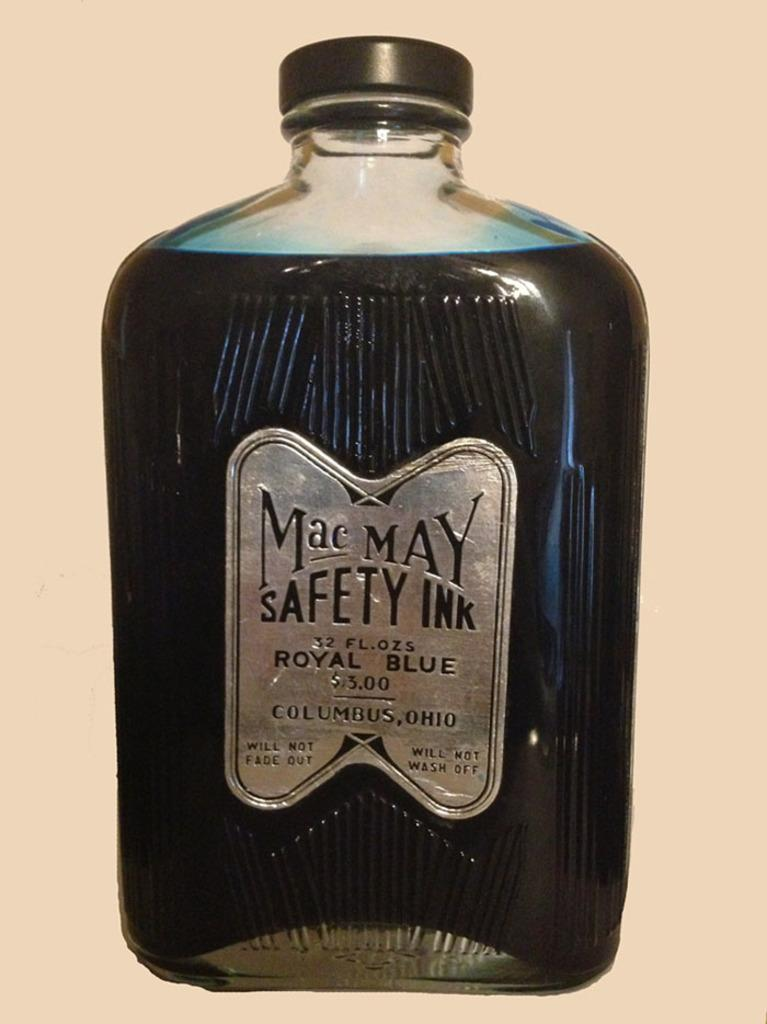What object can be seen in the image? There is a bottle in the image. What is written on the bottle? The bottle has "Mac May safety" written on it. How many pizzas are visible on the moon in the image? There are no pizzas or moons visible in the image; it only features a bottle with "Mac May safety" written on it. 